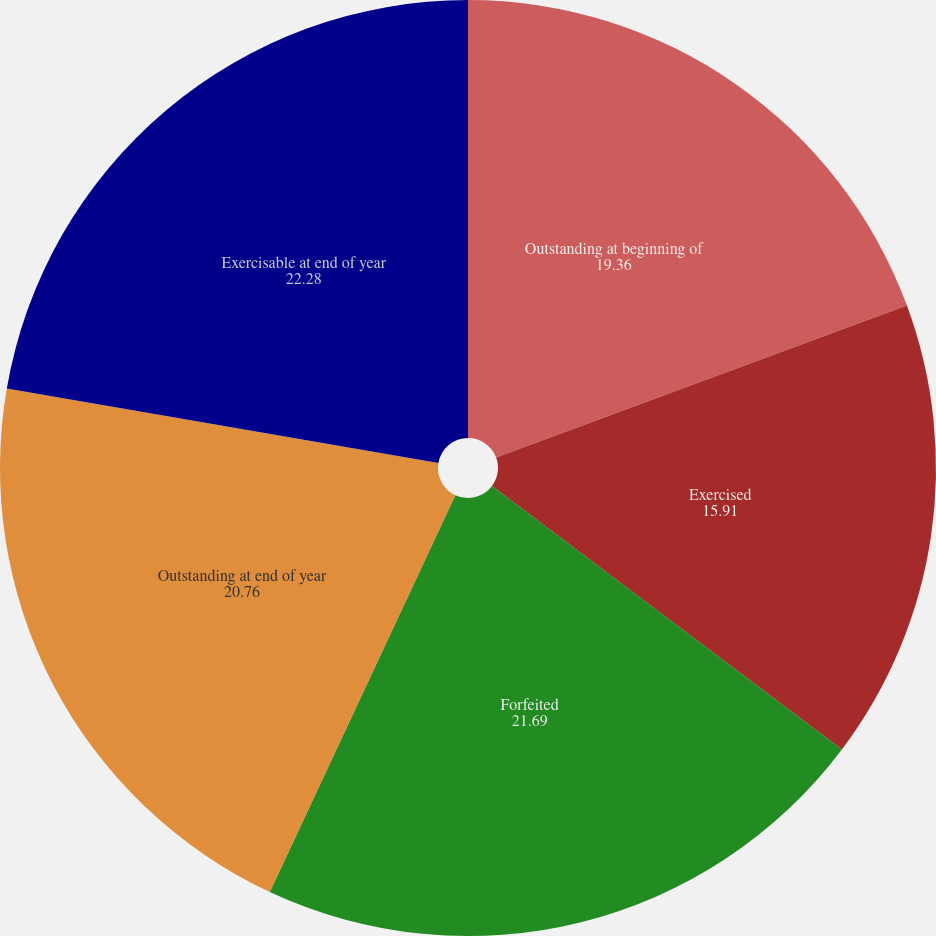<chart> <loc_0><loc_0><loc_500><loc_500><pie_chart><fcel>Outstanding at beginning of<fcel>Exercised<fcel>Forfeited<fcel>Outstanding at end of year<fcel>Exercisable at end of year<nl><fcel>19.36%<fcel>15.91%<fcel>21.69%<fcel>20.76%<fcel>22.28%<nl></chart> 